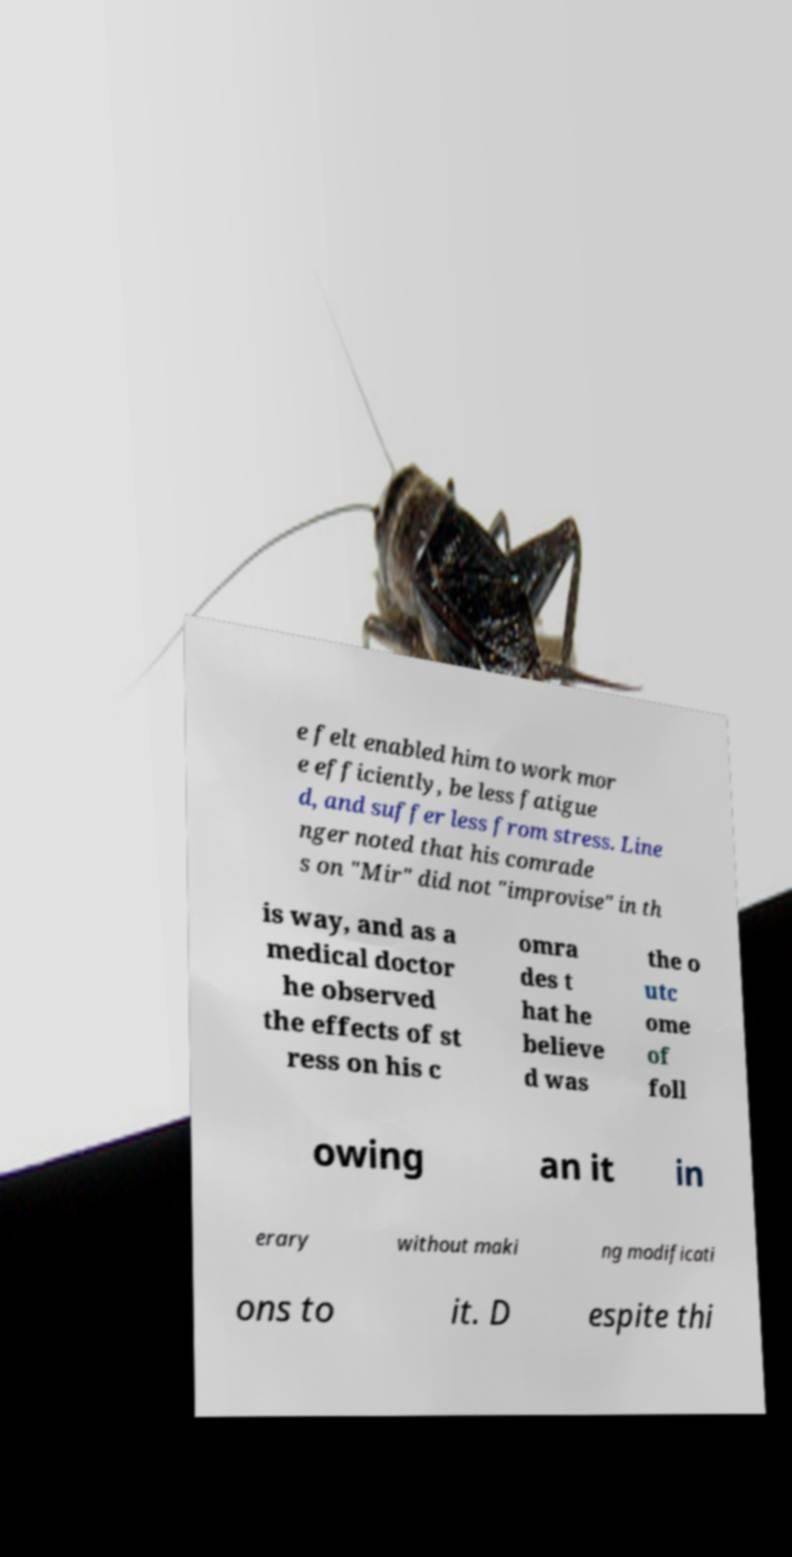For documentation purposes, I need the text within this image transcribed. Could you provide that? e felt enabled him to work mor e efficiently, be less fatigue d, and suffer less from stress. Line nger noted that his comrade s on "Mir" did not "improvise" in th is way, and as a medical doctor he observed the effects of st ress on his c omra des t hat he believe d was the o utc ome of foll owing an it in erary without maki ng modificati ons to it. D espite thi 